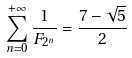<formula> <loc_0><loc_0><loc_500><loc_500>\sum _ { n = 0 } ^ { + \infty } \frac { 1 } { F _ { 2 ^ { n } } } = \frac { 7 - \sqrt { 5 } } { 2 }</formula> 